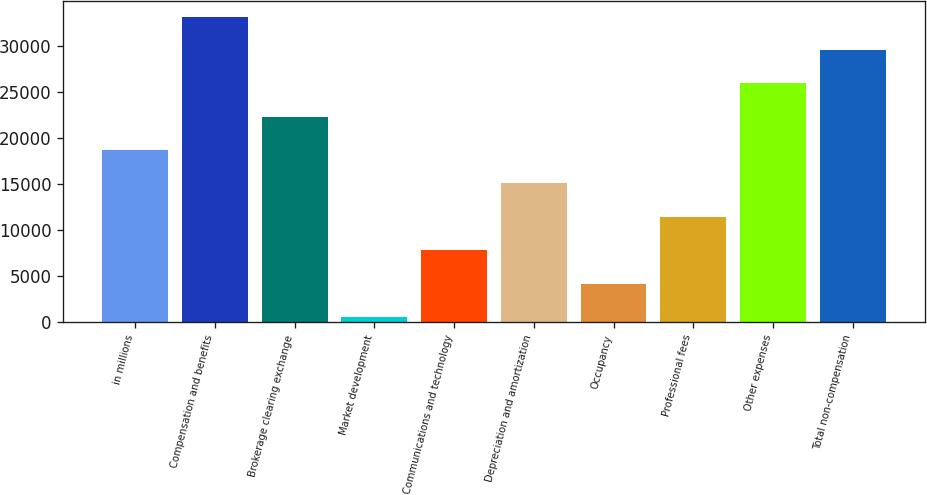Convert chart. <chart><loc_0><loc_0><loc_500><loc_500><bar_chart><fcel>in millions<fcel>Compensation and benefits<fcel>Brokerage clearing exchange<fcel>Market development<fcel>Communications and technology<fcel>Depreciation and amortization<fcel>Occupancy<fcel>Professional fees<fcel>Other expenses<fcel>Total non-compensation<nl><fcel>18678.5<fcel>33175.7<fcel>22302.8<fcel>557<fcel>7805.6<fcel>15054.2<fcel>4181.3<fcel>11429.9<fcel>25927.1<fcel>29551.4<nl></chart> 